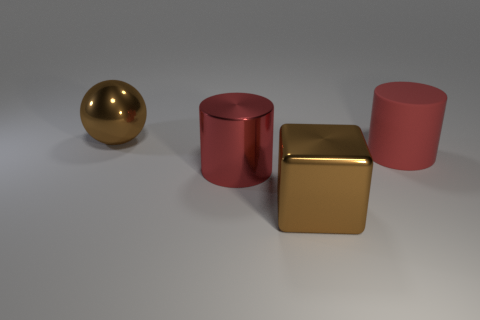Do the big rubber cylinder and the big cylinder that is to the left of the large brown cube have the same color?
Your answer should be compact. Yes. What is the shape of the big rubber object?
Offer a terse response. Cylinder. There is a brown shiny object that is behind the red metallic cylinder; does it have the same shape as the rubber thing?
Ensure brevity in your answer.  No. Are there any large shiny objects that have the same color as the large metal sphere?
Ensure brevity in your answer.  Yes. Does the rubber thing have the same shape as the red metallic object?
Your answer should be very brief. Yes. How many large things are either brown cylinders or red metallic objects?
Your answer should be very brief. 1. What is the color of the ball?
Give a very brief answer. Brown. There is a large brown thing on the right side of the brown thing that is behind the big metal cube; what shape is it?
Ensure brevity in your answer.  Cube. Is there a thing that has the same material as the large brown ball?
Keep it short and to the point. Yes. What number of green things are either spheres or blocks?
Offer a terse response. 0. 